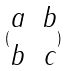<formula> <loc_0><loc_0><loc_500><loc_500>( \begin{matrix} a & b \\ b & c \end{matrix} )</formula> 